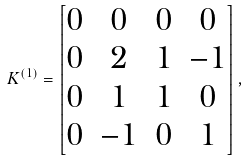<formula> <loc_0><loc_0><loc_500><loc_500>K ^ { ( 1 ) } = \begin{bmatrix} 0 & 0 & 0 & 0 \\ 0 & 2 & 1 & - 1 \\ 0 & 1 & 1 & 0 \\ 0 & - 1 & 0 & 1 \end{bmatrix} ,</formula> 